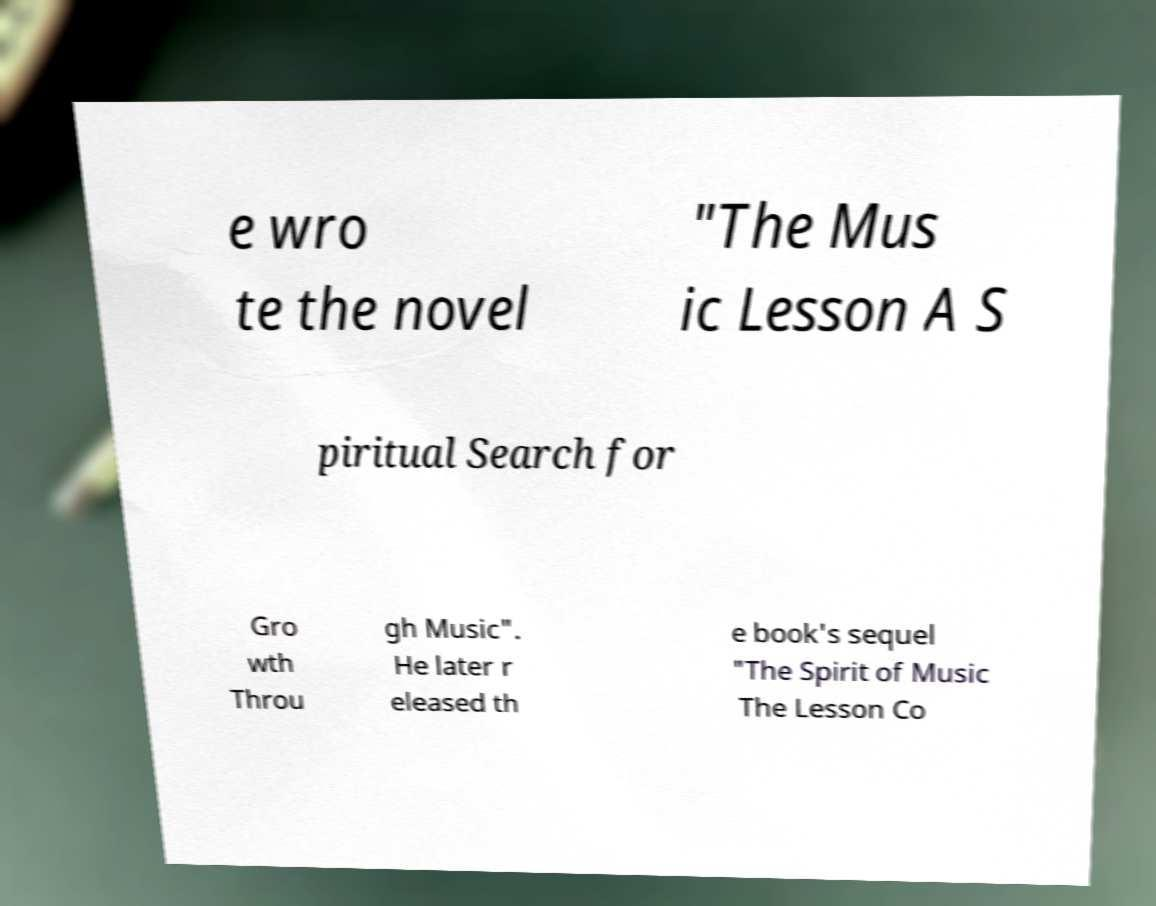There's text embedded in this image that I need extracted. Can you transcribe it verbatim? e wro te the novel "The Mus ic Lesson A S piritual Search for Gro wth Throu gh Music". He later r eleased th e book's sequel "The Spirit of Music The Lesson Co 